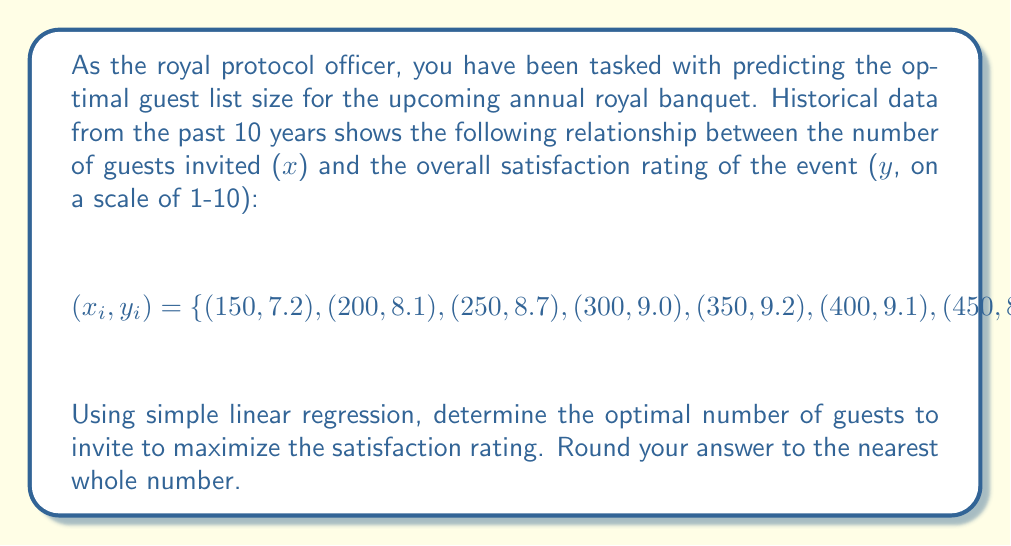Solve this math problem. To solve this problem, we'll use simple linear regression to model the relationship between the number of guests (x) and the satisfaction rating (y), then find the maximum point of the resulting quadratic function.

1. First, we need to recognize that the relationship appears to be quadratic rather than linear. We'll use the model:

   $$y = ax^2 + bx + c$$

2. To fit this model, we'll use the normal equations for quadratic regression:

   $$\begin{bmatrix}
   \sum x_i^4 & \sum x_i^3 & \sum x_i^2 \\
   \sum x_i^3 & \sum x_i^2 & \sum x_i \\
   \sum x_i^2 & \sum x_i & n
   \end{bmatrix}
   \begin{bmatrix}
   a \\
   b \\
   c
   \end{bmatrix} =
   \begin{bmatrix}
   \sum x_i^2y_i \\
   \sum x_iy_i \\
   \sum y_i
   \end{bmatrix}$$

3. Calculating the sums (you would typically use software for this):

   $$\sum x_i^4 = 5.7875 \times 10^{10}$$
   $$\sum x_i^3 = 8.7375 \times 10^8$$
   $$\sum x_i^2 = 1.3875 \times 10^7$$
   $$\sum x_i = 3750$$
   $$n = 10$$
   $$\sum x_i^2y_i = 1.20725 \times 10^8$$
   $$\sum x_iy_i = 3.215 \times 10^6$$
   $$\sum y_i = 84.8$$

4. Solving this system of equations (again, typically done with software), we get:

   $$a \approx -5.6 \times 10^{-5}$$
   $$b \approx 0.0416$$
   $$c \approx 1.263$$

5. Our quadratic model is thus:

   $$y = -5.6 \times 10^{-5}x^2 + 0.0416x + 1.263$$

6. To find the maximum of this function, we differentiate and set to zero:

   $$\frac{dy}{dx} = -11.2 \times 10^{-5}x + 0.0416 = 0$$

7. Solving this equation:

   $$x = \frac{0.0416}{11.2 \times 10^{-5}} \approx 371.43$$

8. Rounding to the nearest whole number:

   $$x \approx 371$$

Therefore, the optimal number of guests to invite is 371.
Answer: 371 guests 